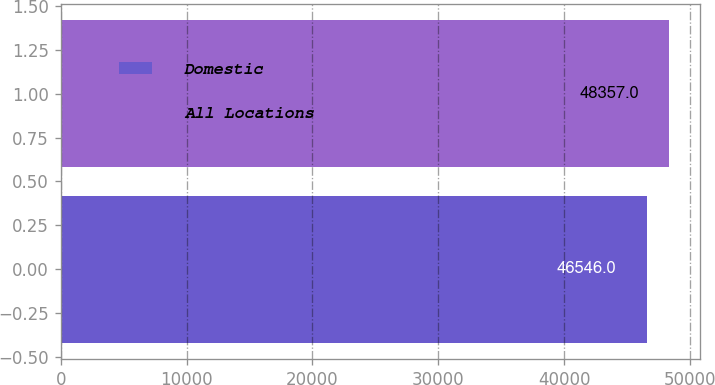Convert chart. <chart><loc_0><loc_0><loc_500><loc_500><bar_chart><fcel>Domestic<fcel>All Locations<nl><fcel>46546<fcel>48357<nl></chart> 